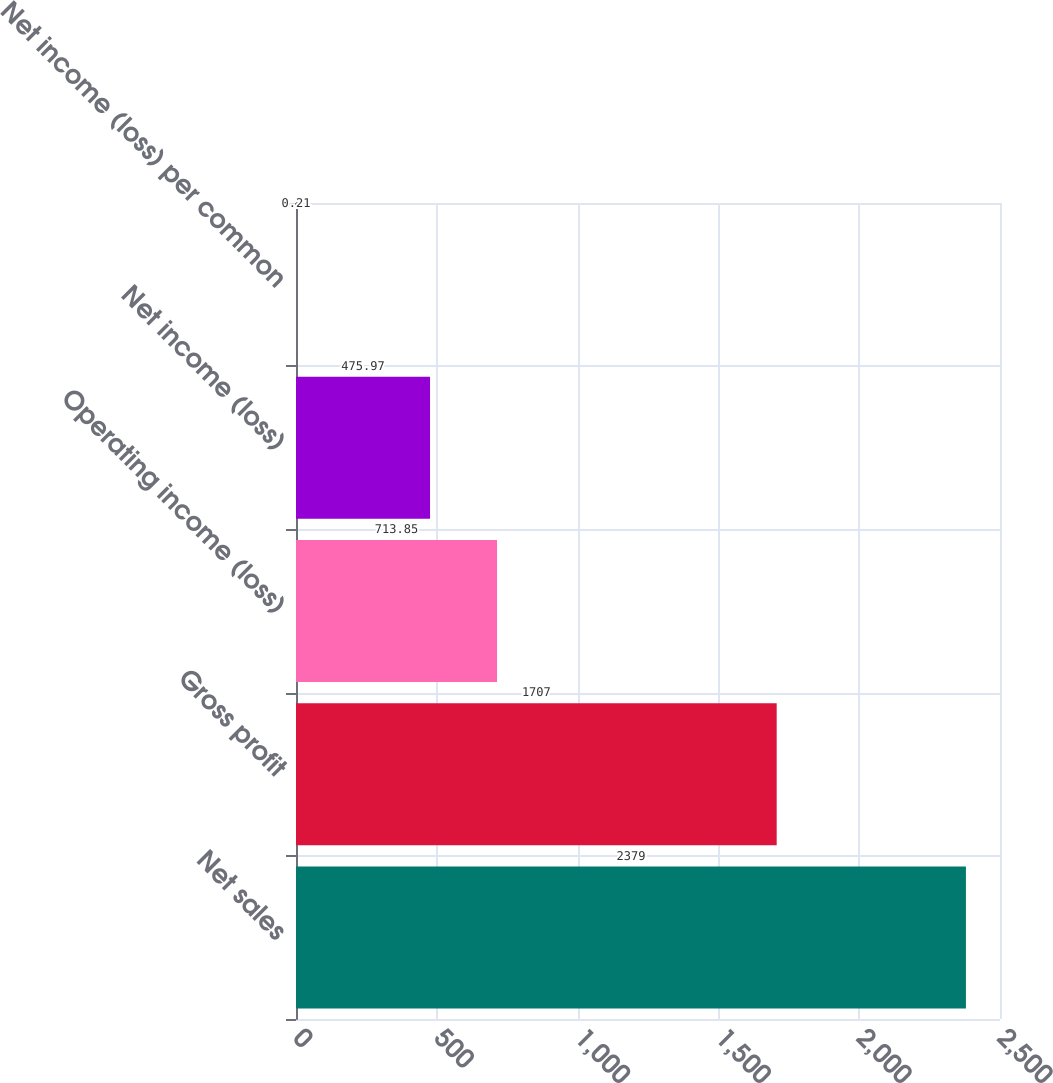Convert chart to OTSL. <chart><loc_0><loc_0><loc_500><loc_500><bar_chart><fcel>Net sales<fcel>Gross profit<fcel>Operating income (loss)<fcel>Net income (loss)<fcel>Net income (loss) per common<nl><fcel>2379<fcel>1707<fcel>713.85<fcel>475.97<fcel>0.21<nl></chart> 